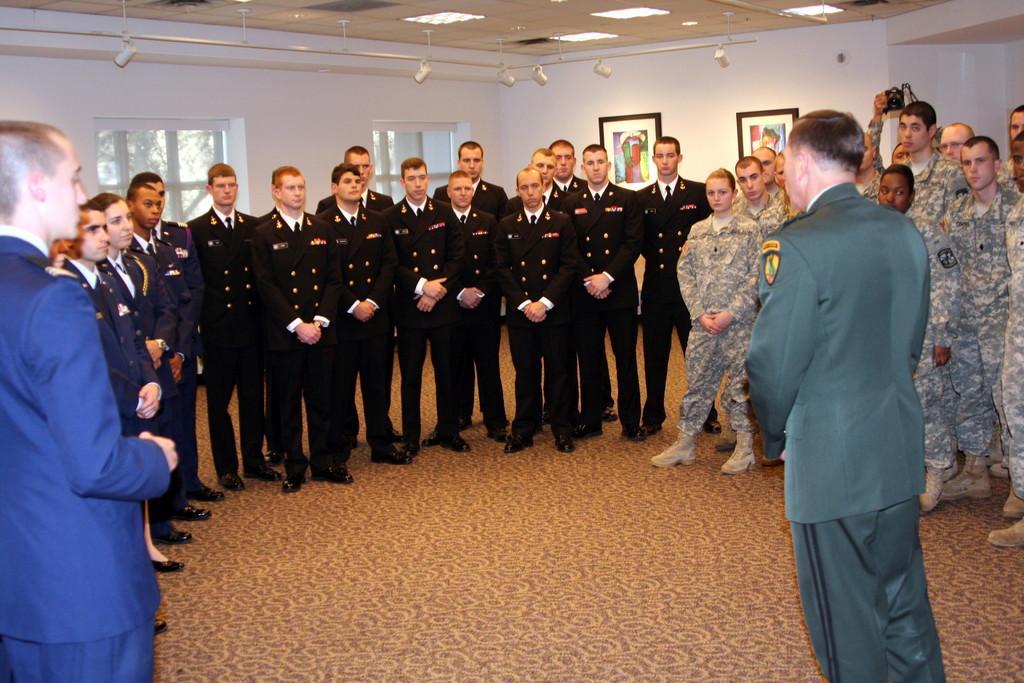Could you give a brief overview of what you see in this image? In this picture we can see a group of people standing. We can see a person holding a camera. There are frames, lights and glass objects visible in the background. We can see a few leaves through these glass objects. 